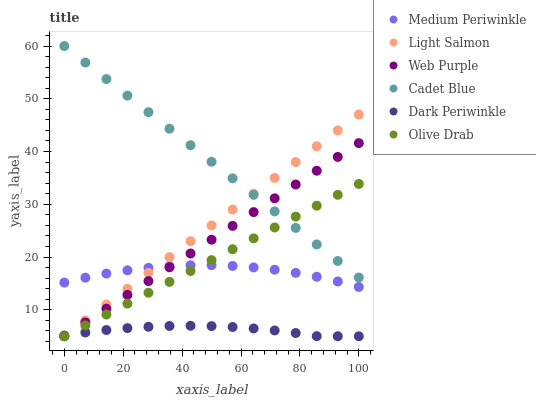Does Dark Periwinkle have the minimum area under the curve?
Answer yes or no. Yes. Does Cadet Blue have the maximum area under the curve?
Answer yes or no. Yes. Does Medium Periwinkle have the minimum area under the curve?
Answer yes or no. No. Does Medium Periwinkle have the maximum area under the curve?
Answer yes or no. No. Is Olive Drab the smoothest?
Answer yes or no. Yes. Is Medium Periwinkle the roughest?
Answer yes or no. Yes. Is Cadet Blue the smoothest?
Answer yes or no. No. Is Cadet Blue the roughest?
Answer yes or no. No. Does Light Salmon have the lowest value?
Answer yes or no. Yes. Does Medium Periwinkle have the lowest value?
Answer yes or no. No. Does Cadet Blue have the highest value?
Answer yes or no. Yes. Does Medium Periwinkle have the highest value?
Answer yes or no. No. Is Dark Periwinkle less than Medium Periwinkle?
Answer yes or no. Yes. Is Medium Periwinkle greater than Dark Periwinkle?
Answer yes or no. Yes. Does Web Purple intersect Cadet Blue?
Answer yes or no. Yes. Is Web Purple less than Cadet Blue?
Answer yes or no. No. Is Web Purple greater than Cadet Blue?
Answer yes or no. No. Does Dark Periwinkle intersect Medium Periwinkle?
Answer yes or no. No. 